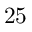<formula> <loc_0><loc_0><loc_500><loc_500>2 5</formula> 